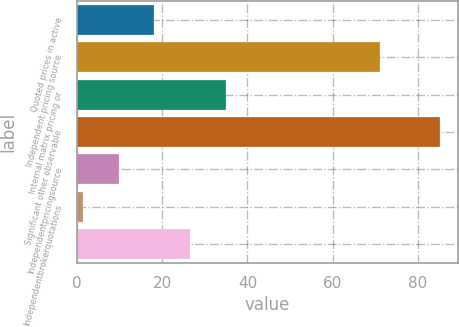Convert chart. <chart><loc_0><loc_0><loc_500><loc_500><bar_chart><fcel>Quoted prices in active<fcel>Independent pricing source<fcel>Internal matrix pricing or<fcel>Significant other observable<fcel>Independentpricingsource<fcel>Independentbrokerquotations<fcel>Unnamed: 6<nl><fcel>18.16<fcel>71<fcel>34.92<fcel>85.2<fcel>9.78<fcel>1.4<fcel>26.54<nl></chart> 